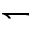<formula> <loc_0><loc_0><loc_500><loc_500>\leftharpoondown</formula> 